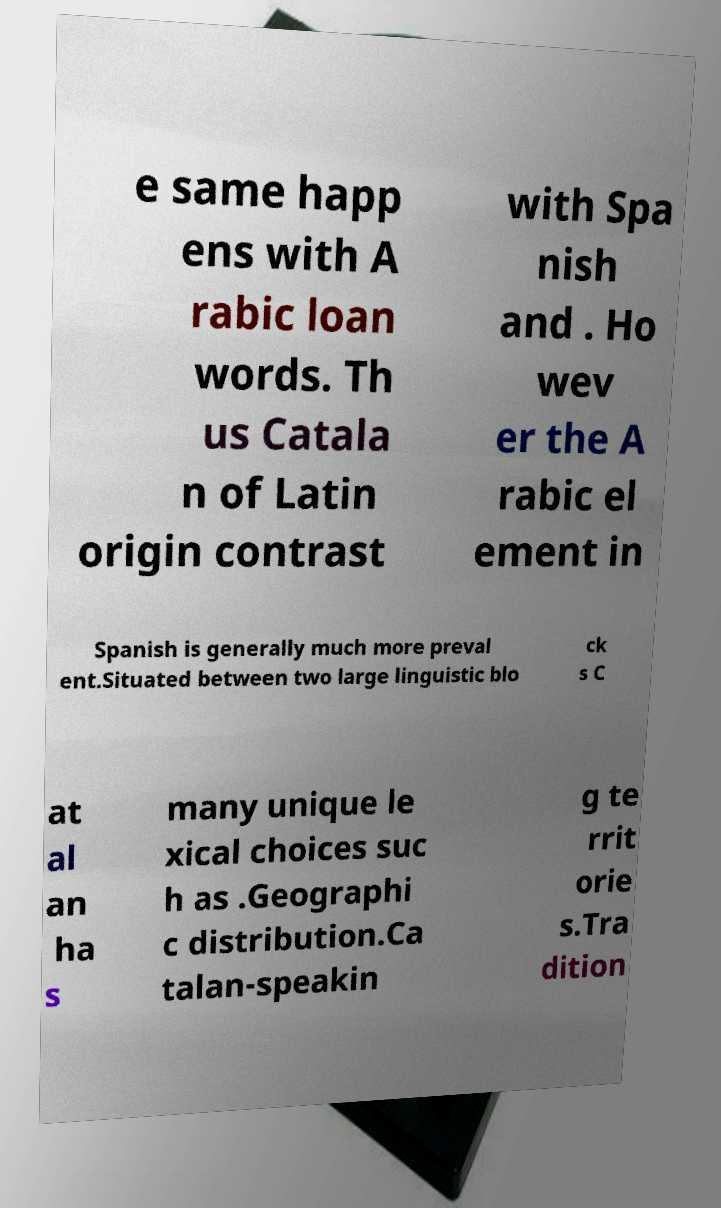I need the written content from this picture converted into text. Can you do that? e same happ ens with A rabic loan words. Th us Catala n of Latin origin contrast with Spa nish and . Ho wev er the A rabic el ement in Spanish is generally much more preval ent.Situated between two large linguistic blo ck s C at al an ha s many unique le xical choices suc h as .Geographi c distribution.Ca talan-speakin g te rrit orie s.Tra dition 